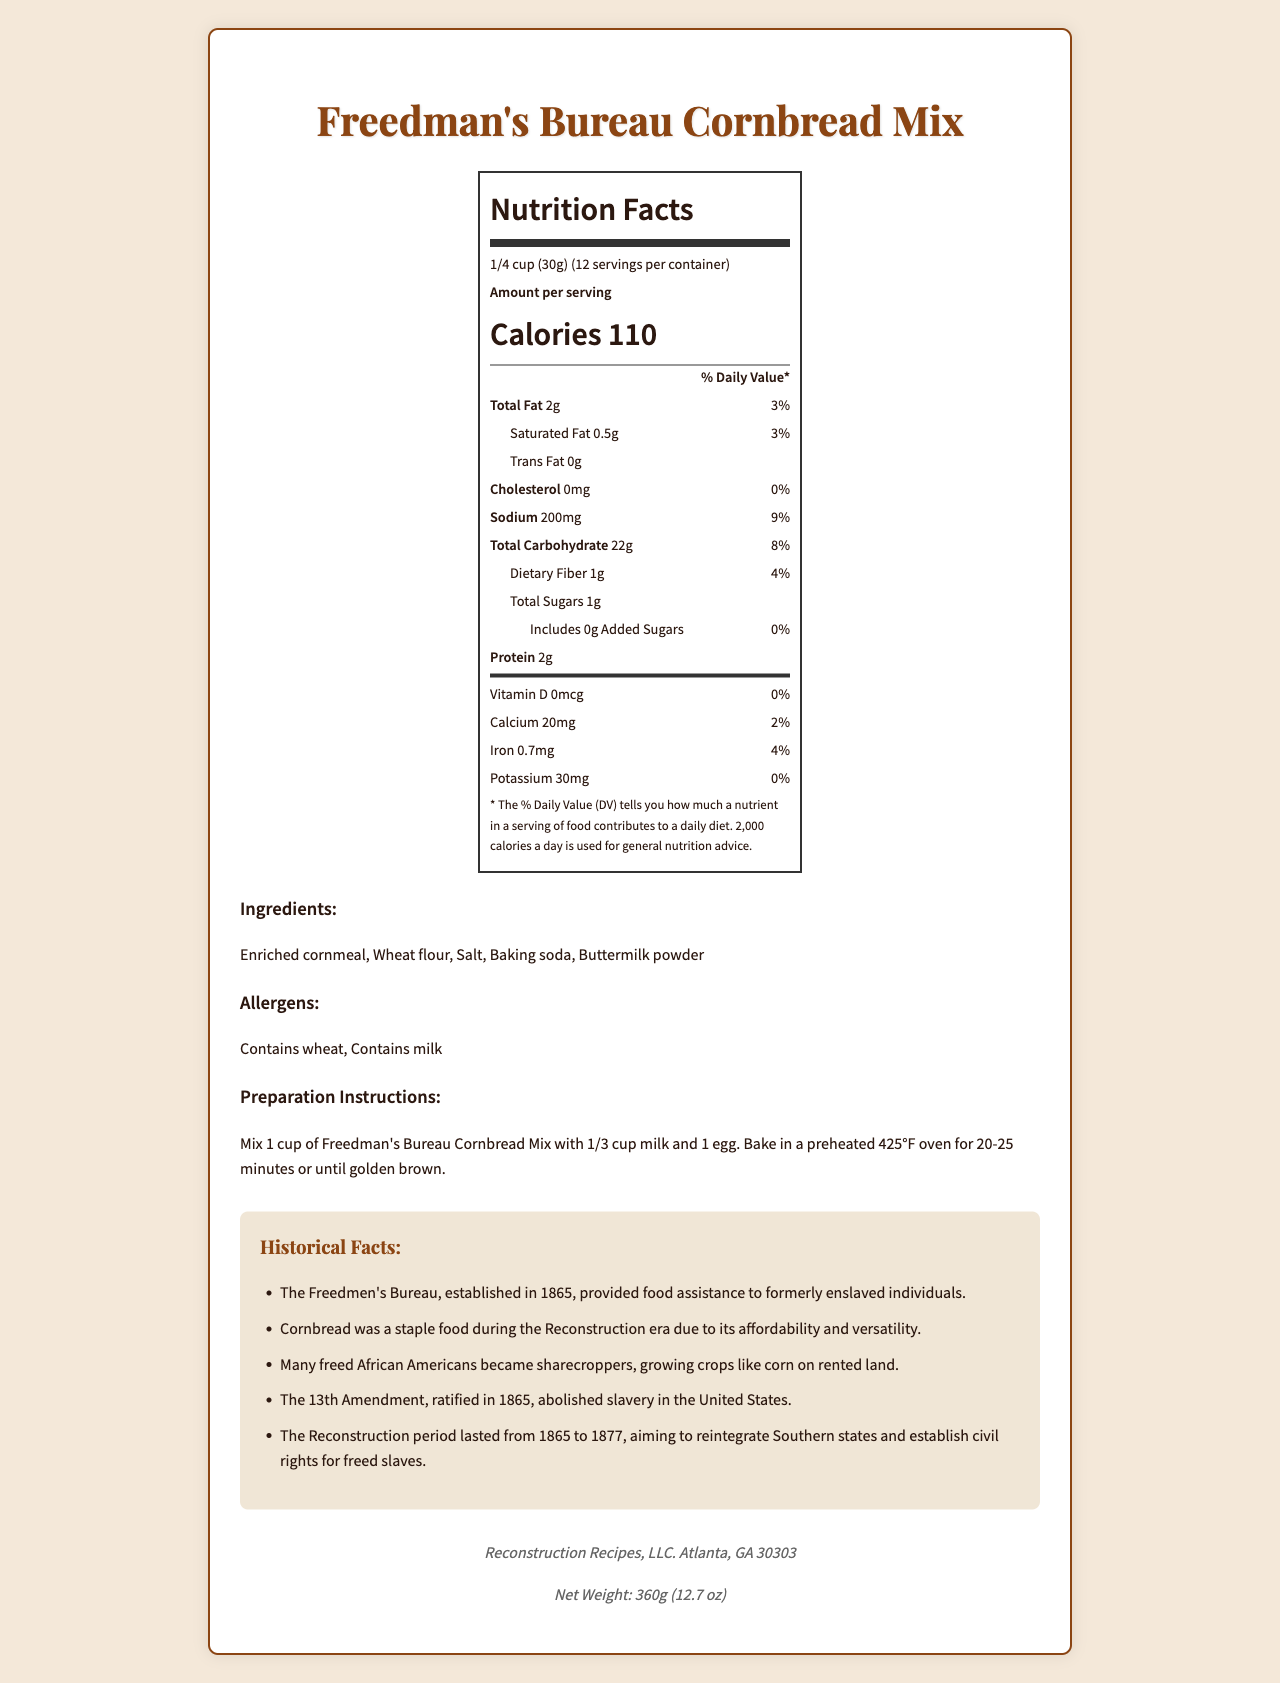what is the serving size? The serving size is explicitly stated at the top of the Nutrition Facts information.
Answer: 1/4 cup (30g) how many servings are in the container? The number of servings per container is provided directly below the serving size information.
Answer: 12 how many calories are in one serving? The calories per serving are prominently displayed in the Nutrition Facts section.
Answer: 110 what is the total fat content per serving? The total fat content per serving is listed in the Nutrition Facts section under "Total Fat."
Answer: 2g which nutrient has the highest daily value percentage? The daily value percentage for sodium is 9%, which is the highest among the listed nutrients.
Answer: Sodium what are two historical facts mentioned? These historical facts are highlighted in the "Historical Facts" section of the document.
Answer: The Freedmen's Bureau provided food assistance to formerly enslaved individuals and Cornbread was a staple food during the Reconstruction era. What is the daily value percentage for protein? The Nutrition Facts label includes the amount of protein (2g) but does not provide a daily value percentage.
Answer: No daily value percentage for protein is given. What ingredients are listed for the product? The ingredients are listed in the "Ingredients" section of the document.
Answer: Enriched cornmeal, Wheat flour, Salt, Baking soda, Buttermilk powder what is the net weight of the product? The net weight is mentioned at the bottom of the document in the "company info" section.
Answer: 360g (12.7 oz) which allergens are present in the product? The allergens are listed in the "Allergens" section of the document.
Answer: Wheat and milk Mix what ingredients to prepare the cornbread? The preparation instructions detail mixing these ingredients and baking.
Answer: 1 cup of cornbread mix, 1/3 cup milk, and 1 egg What is the amount of dietary fiber per serving? A. 1g B. 2g C. 3g D. 4g The amount of dietary fiber per serving is listed as 1g in the Nutrition Facts section.
Answer: A. 1g What is the recommended serving size? A. 1/3 cup B. 1/4 cup C. 1/2 cup D. 1/8 cup The serving size, 1/4 cup (30g), is specified in the Nutrition Facts section.
Answer: B. 1/4 cup Which of the following is NOT mentioned as a historical fact on the label? 1. Many freed African Americans became sharecroppers 2. The 14th Amendment established citizenship rights 3. The Reconstruction period lasted from 1865 to 1877 4. The 13th Amendment abolished slavery The document mentions the 13th Amendment, but not the 14th Amendment.
Answer: 2. The 14th Amendment established citizenship rights Was cornbread affordable and versatile during the Reconstruction era? The historical facts section highlights cornbread's importance as a staple food due to its affordability and versatility.
Answer: Yes Did the product's preparation instructions mention adding wheat flour separately? The preparation instructions do not mention adding wheat flour separately; it is included in the mix.
Answer: No Summarize the main idea of the document. The document aims to inform consumers about the nutritional content, ingredients, and preparation of the cornbread mix while highlighting historical facts from the Reconstruction era.
Answer: The document provides nutritional information, ingredients, preparation instructions, and historical facts for the "Freedman's Bureau Cornbread Mix," a commemorative food product inspired by Reconstruction-era cuisine. How long should you bake the cornbread in the oven? The preparation instructions specify baking time in a preheated 425°F oven.
Answer: 20-25 minutes When was the 13th Amendment ratified? The historical facts section states that the 13th Amendment, which abolished slavery, was ratified in 1865.
Answer: 1865 What is the contact address of the company? The company information section at the bottom provides this address.
Answer: Atlanta, GA 30303 Who established the Freedmen's Bureau? The document mentions the Freedmen's Bureau but does not specify who established it.
Answer: Not enough information 